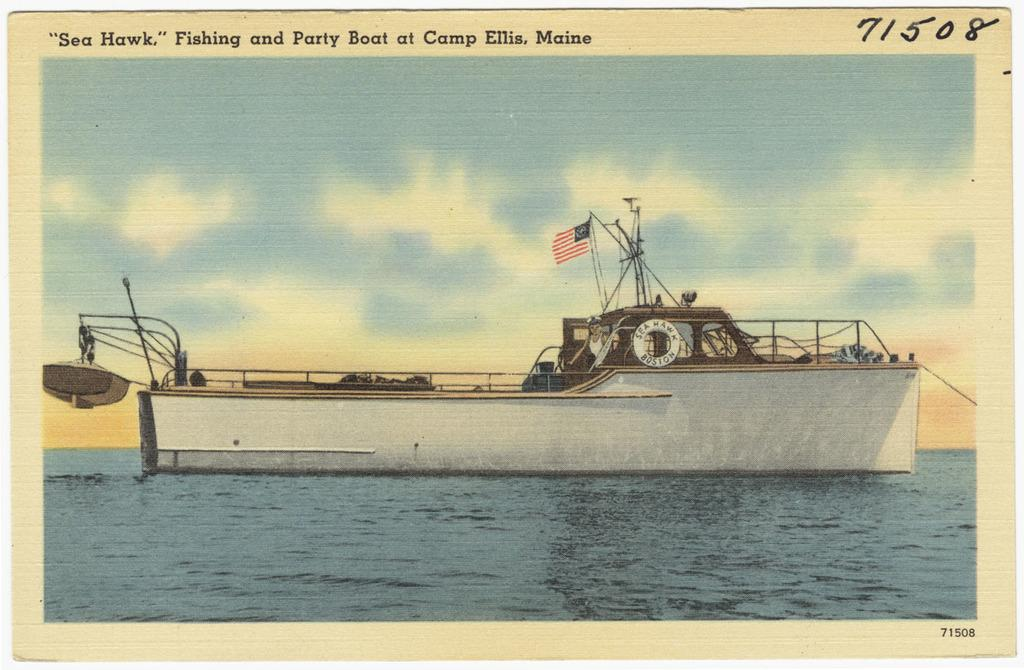What is the main subject of the image? The main subject of the image is a boat. Where is the boat located? The boat is on the water. What else can be seen in the image besides the boat? There is a flag in the image. What is visible in the background of the image? The sky is visible in the background of the image. What type of fruit is hanging from the flag in the image? There is no fruit hanging from the flag in the image; it is a flag with no fruit present. How does the boat show respect to the flag in the image? The boat does not show respect to the flag in the image; it is simply a boat on the water with a flag nearby. 